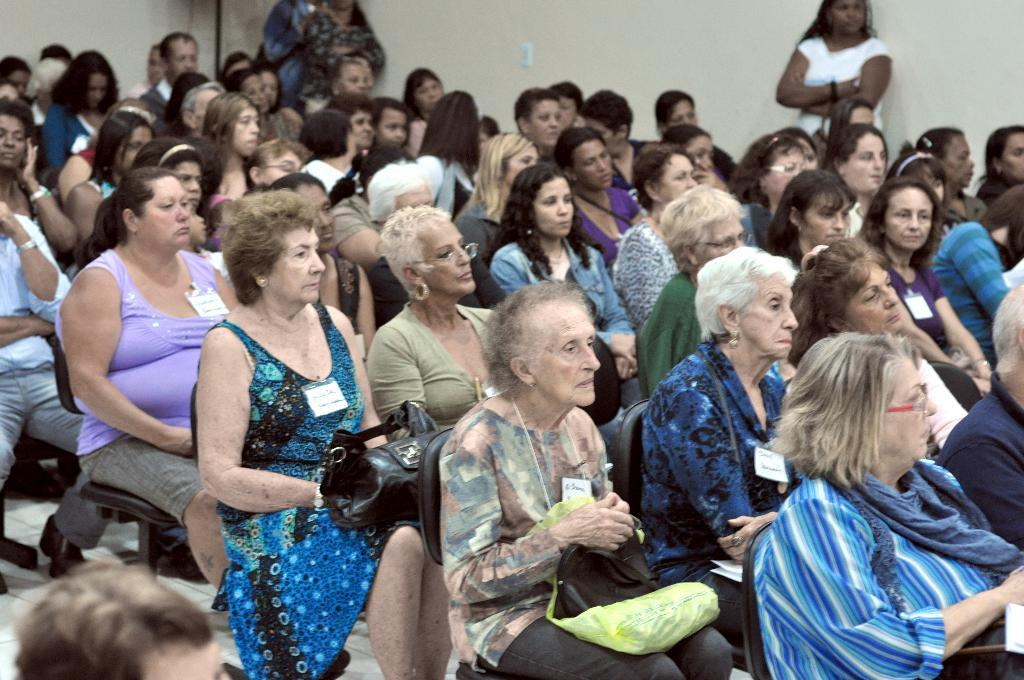What is happening in the middle of the image? There is a group of people sitting in the middle of the image. What are the people sitting on? The people are sitting on chairs. What direction are the people looking in? The people are looking towards the right side. Can you describe the position of the two persons in the image? There are two persons standing near a wall at the top of the image. What type of wind can be seen blowing through the trees in the image? There are no trees or wind present in the image; it features a group of people sitting on chairs and two persons standing near a wall. 